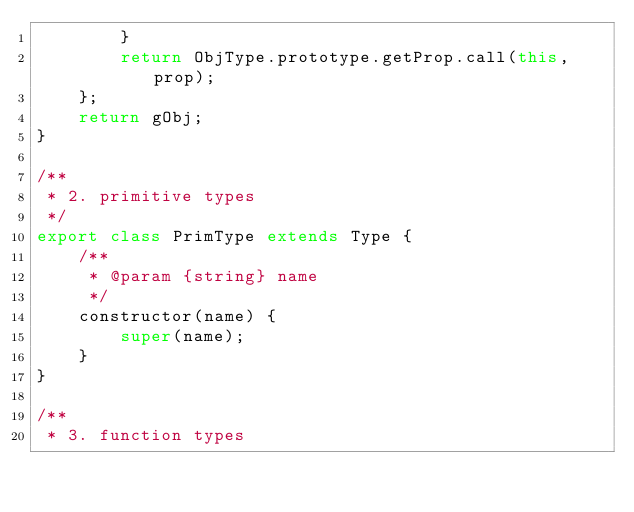Convert code to text. <code><loc_0><loc_0><loc_500><loc_500><_JavaScript_>        }
        return ObjType.prototype.getProp.call(this, prop);
    };
    return gObj;
}

/**
 * 2. primitive types
 */
export class PrimType extends Type {
    /**
     * @param {string} name
     */
    constructor(name) {
        super(name);
    }
}

/**
 * 3. function types</code> 